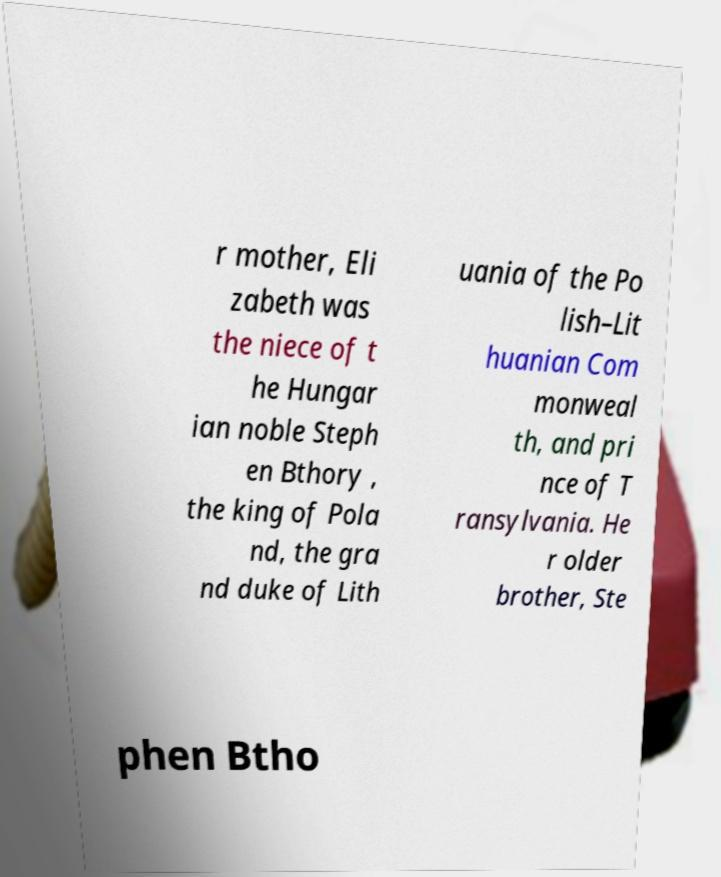For documentation purposes, I need the text within this image transcribed. Could you provide that? r mother, Eli zabeth was the niece of t he Hungar ian noble Steph en Bthory , the king of Pola nd, the gra nd duke of Lith uania of the Po lish–Lit huanian Com monweal th, and pri nce of T ransylvania. He r older brother, Ste phen Btho 